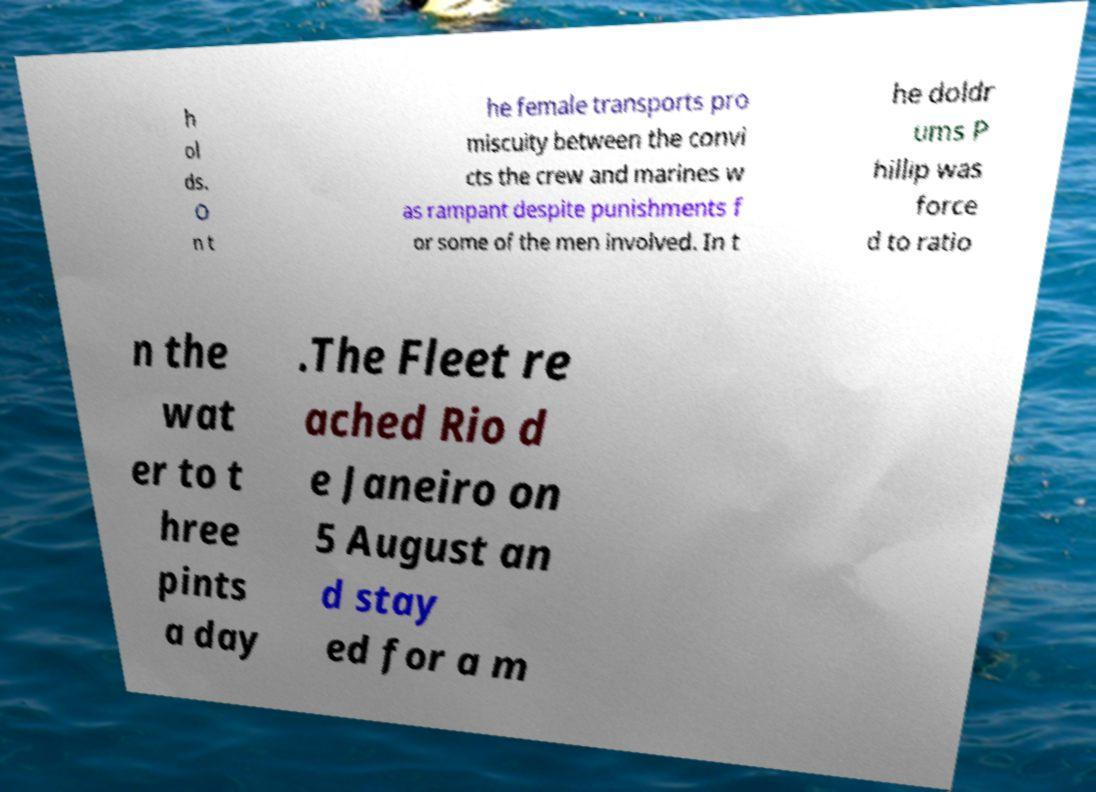What messages or text are displayed in this image? I need them in a readable, typed format. h ol ds. O n t he female transports pro miscuity between the convi cts the crew and marines w as rampant despite punishments f or some of the men involved. In t he doldr ums P hillip was force d to ratio n the wat er to t hree pints a day .The Fleet re ached Rio d e Janeiro on 5 August an d stay ed for a m 